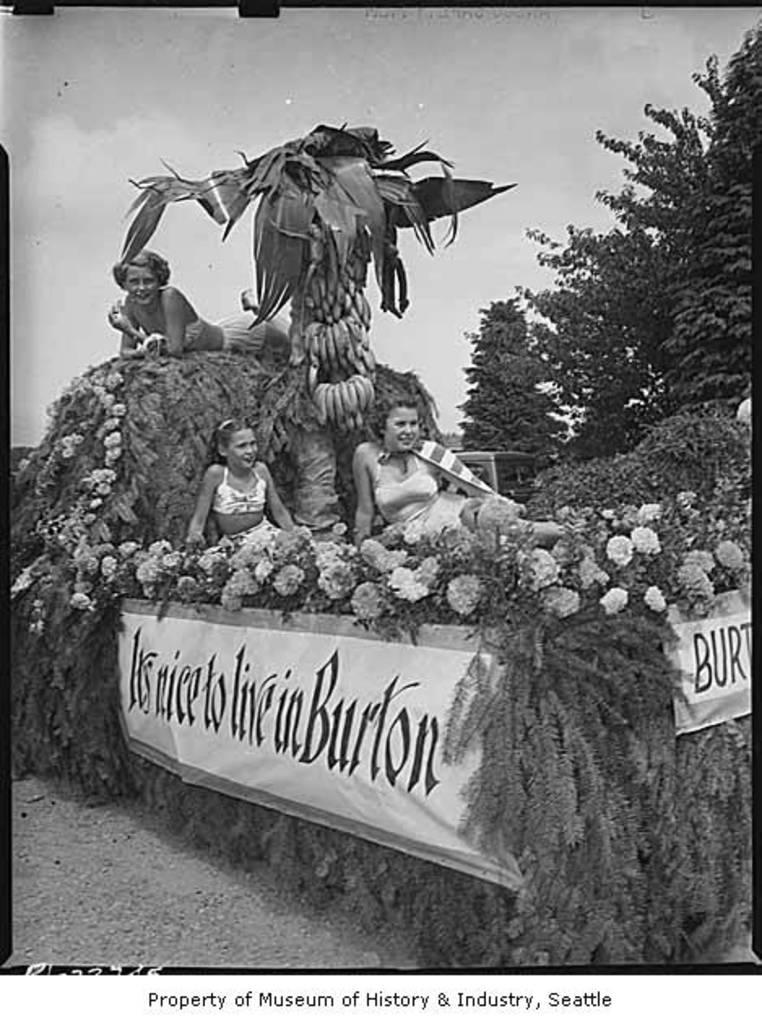What type of plants can be seen in the image? There are flowers and leaves in the image. What objects are made of wood in the image? There are boards in the image. What type of fruit is present in the image? There are bananas in the image. Are there any human figures in the image? Yes, there are people in the image. What is written on the boards in the image? There is writing on the boards in the image. What type of soup is being served in the image? There is no soup present in the image. How does the doll provide comfort to the people in the image? There is no doll present in the image. 